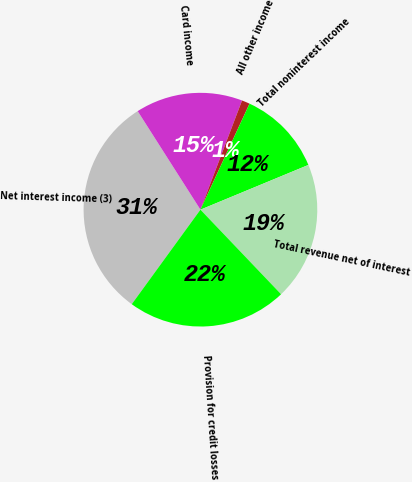<chart> <loc_0><loc_0><loc_500><loc_500><pie_chart><fcel>Net interest income (3)<fcel>Card income<fcel>All other income<fcel>Total noninterest income<fcel>Total revenue net of interest<fcel>Provision for credit losses<nl><fcel>30.97%<fcel>14.82%<fcel>1.11%<fcel>11.84%<fcel>19.13%<fcel>22.12%<nl></chart> 